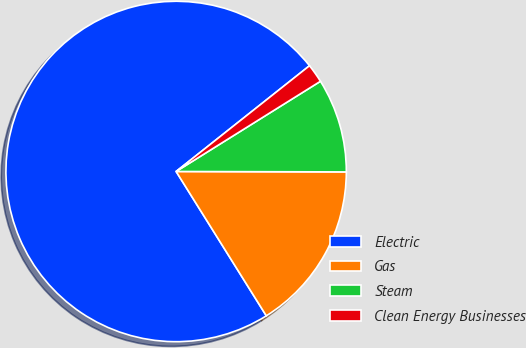Convert chart to OTSL. <chart><loc_0><loc_0><loc_500><loc_500><pie_chart><fcel>Electric<fcel>Gas<fcel>Steam<fcel>Clean Energy Businesses<nl><fcel>73.22%<fcel>16.07%<fcel>8.93%<fcel>1.78%<nl></chart> 